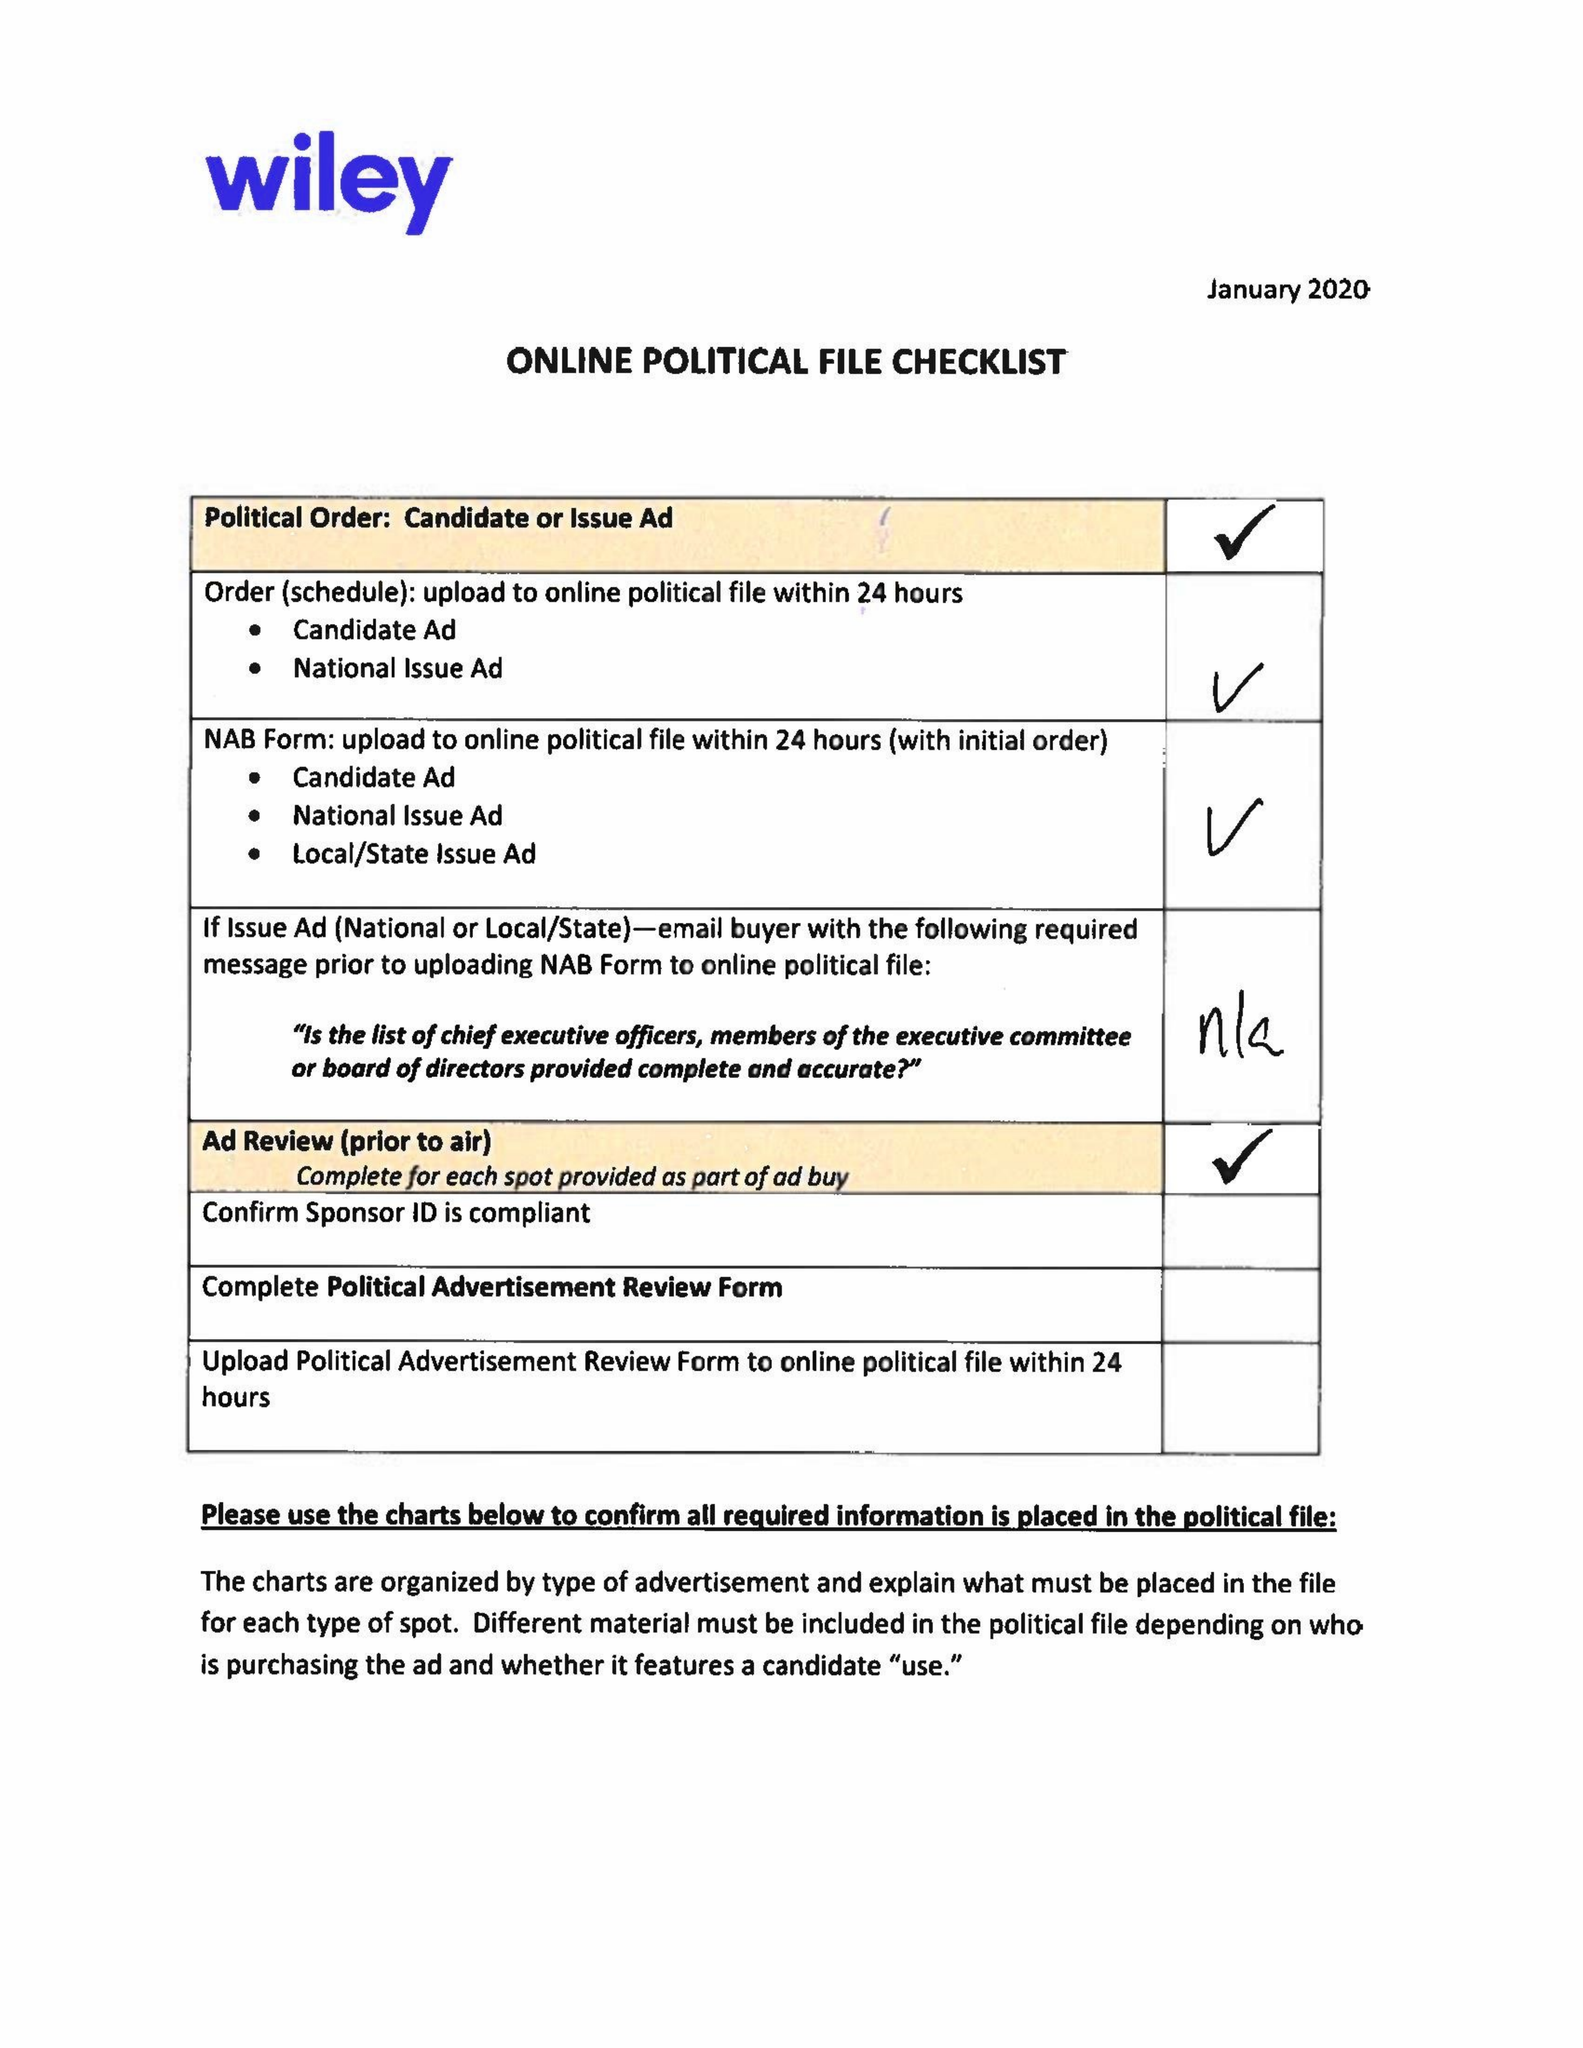What is the value for the advertiser?
Answer the question using a single word or phrase. BRADLEY BYRNE FOR US SENATE 